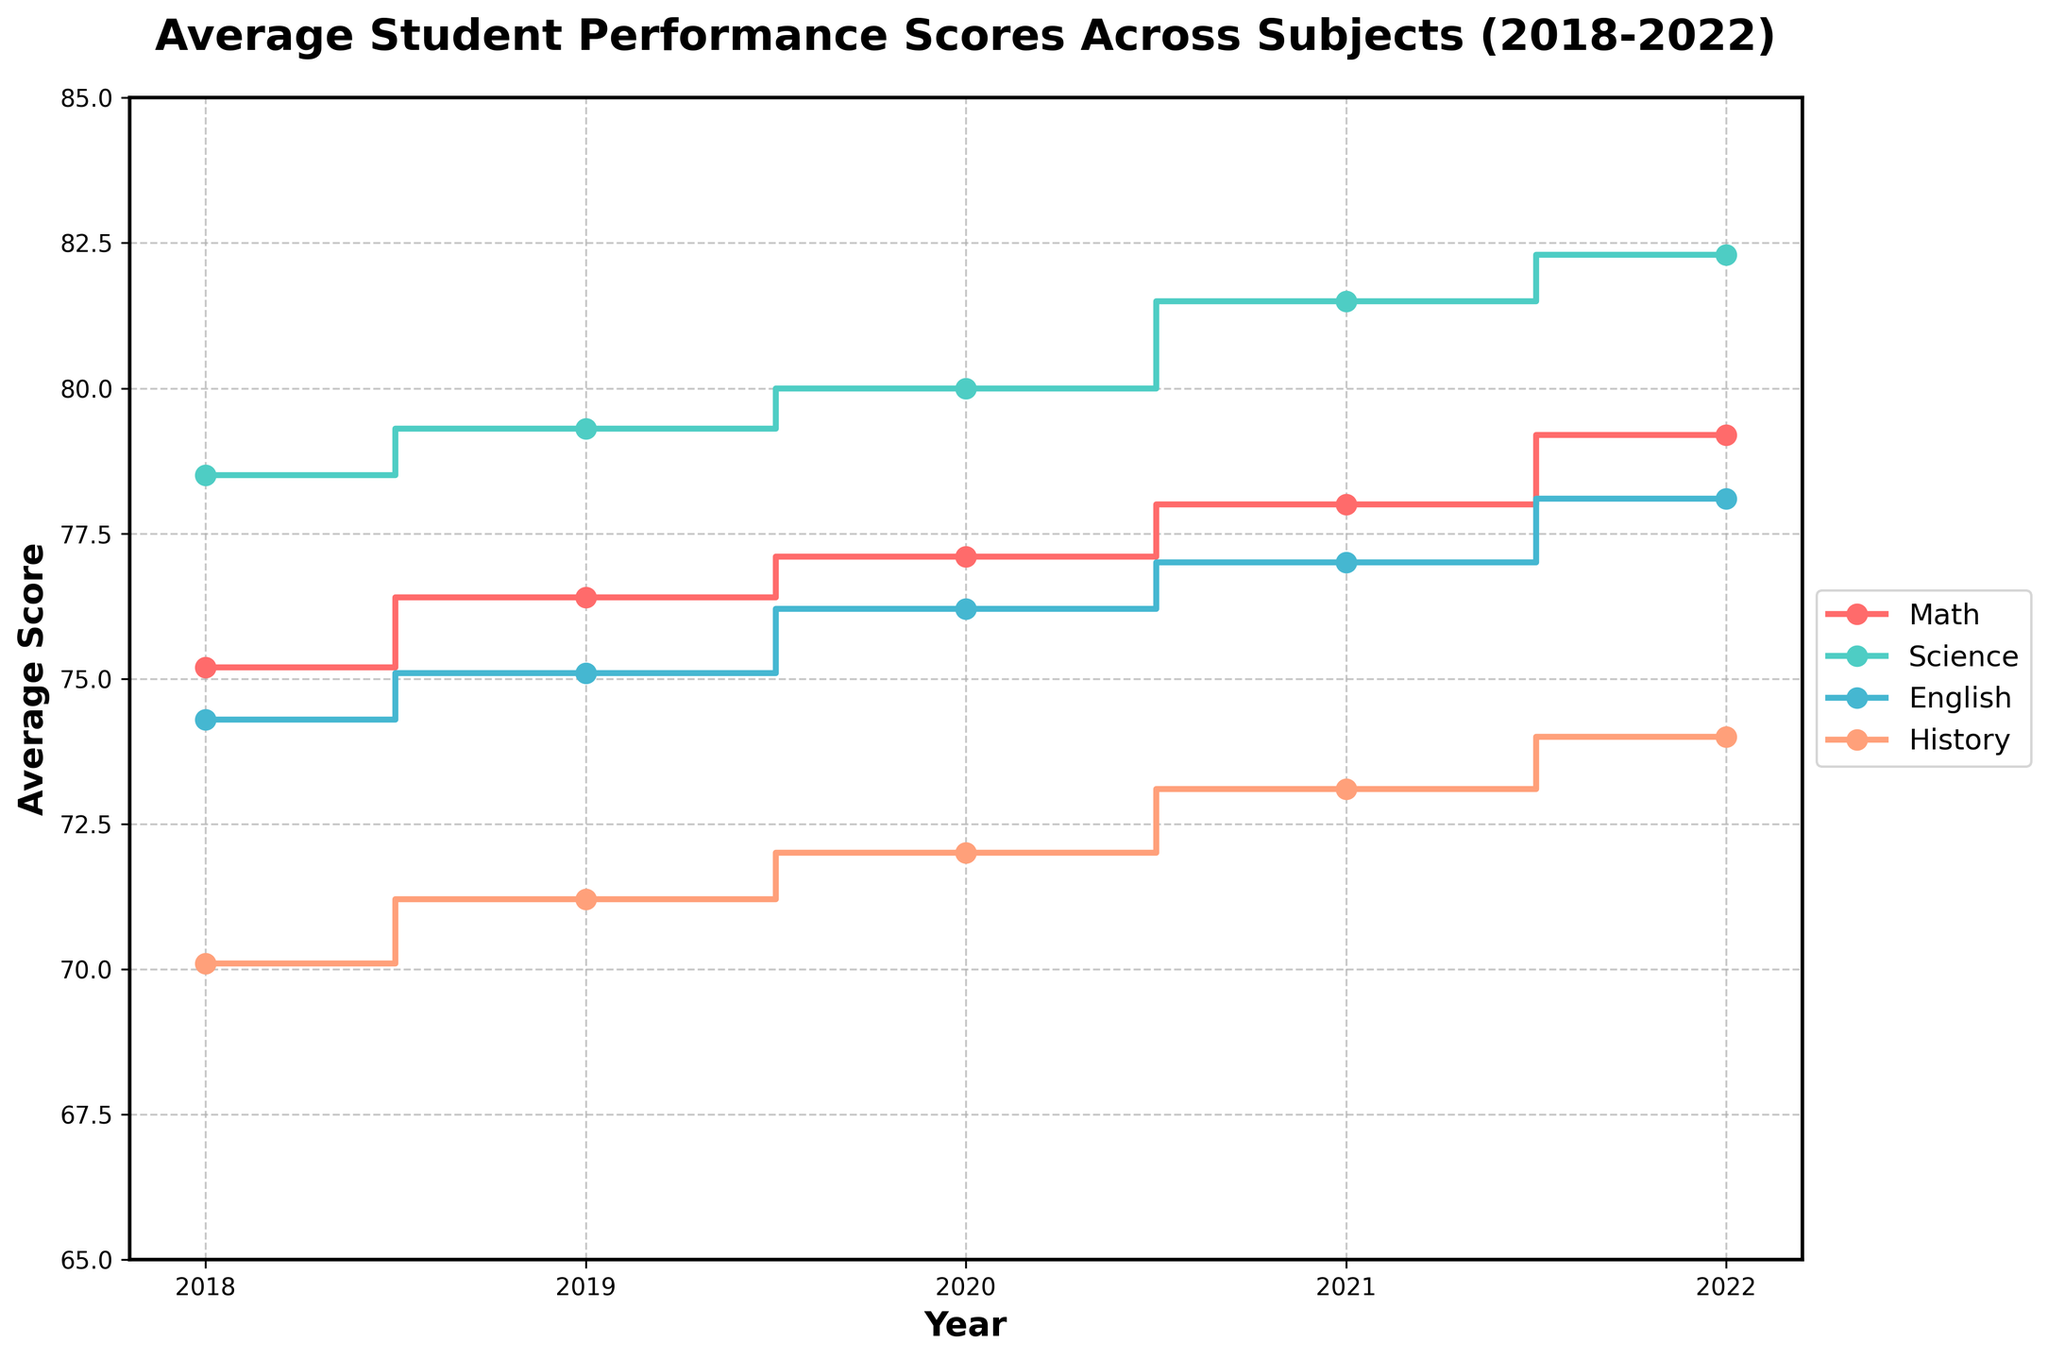What is the title of the figure? The title of the figure is essential to understand the focus of the data being visualized. It is typically located at the top of the plot for reference.
Answer: Average Student Performance Scores Across Subjects (2018-2022) What is the range of the X-axis? The range of the X-axis represents the span of years being analyzed in the plot. This can be inferred by observing the first and last values along the horizontal axis.
Answer: 2018 to 2022 Which subject showed the highest improvement in scores over the five-year period? To determine the highest improvement, compare the scores for each subject from 2018 to 2022. Subtract the 2018 score from the 2022 score for each subject and identify the one with the highest difference.
Answer: Science What was the average Math score over the five years? To find the average, add the Math scores for all the years and divide by the number of years. Calculation: (75.2 + 76.4 + 77.1 + 78.0 + 79.2) / 5 = 77.18
Answer: 77.18 In which year did the English scores see the largest increase compared to the previous year? Compare the year-to-year differences in English scores; find the pair of consecutive years with the largest positive increase. Calculation: 2019-2018 = 75.1-74.3 = 0.8, 2020-2019 = 76.2-75.1 = 1.1, 2021-2020 = 77.0-76.2 = 0.8, 2022-2021 = 78.1-77.0 = 1.1
Answer: 2020 to 2021 or 2021 to 2022 Which subject’s scores remained closest to each other over the years? For each subject, calculate the range (max score - min score). The subject with the smallest range has scores that remained closest together.
Answer: English How much did the History score improve from 2018 to 2022? Subtract the 2018 History score from the 2022 History score. Calculation: 74.0 - 70.1 = 3.9
Answer: 3.9 Between Math and History, which subject had a higher score in 2020? Locate the 2020 scores for both Math and History from the figure and compare them directly.
Answer: Math If you average the scores for each year, which year had the highest average score? For each year, sum the scores of all subjects and then divide by the number of subjects. Compare these averages to find the highest one.
Answer: 2022 Which subject showed the least consistent performance trend over the five years? Identify the subject with the most fluctuations or largest variances in scores over the years. Count the number of up-and-down changes or observe the zigzag pattern in the plot.
Answer: History 